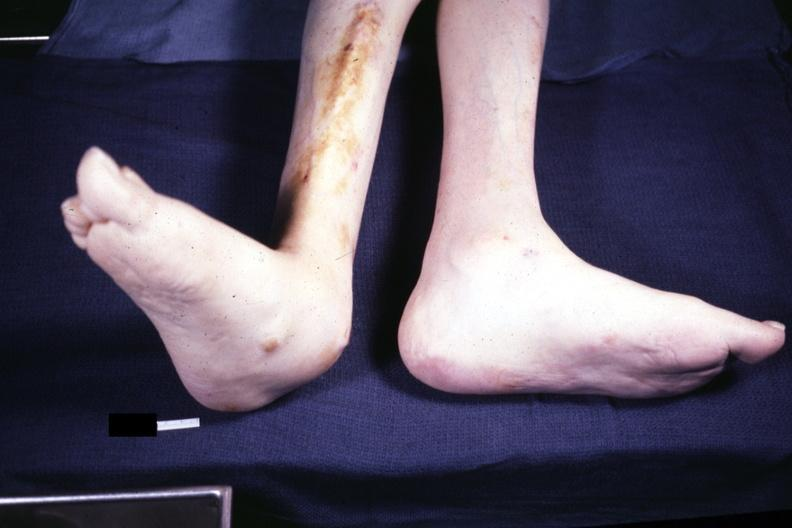s feet present?
Answer the question using a single word or phrase. Yes 